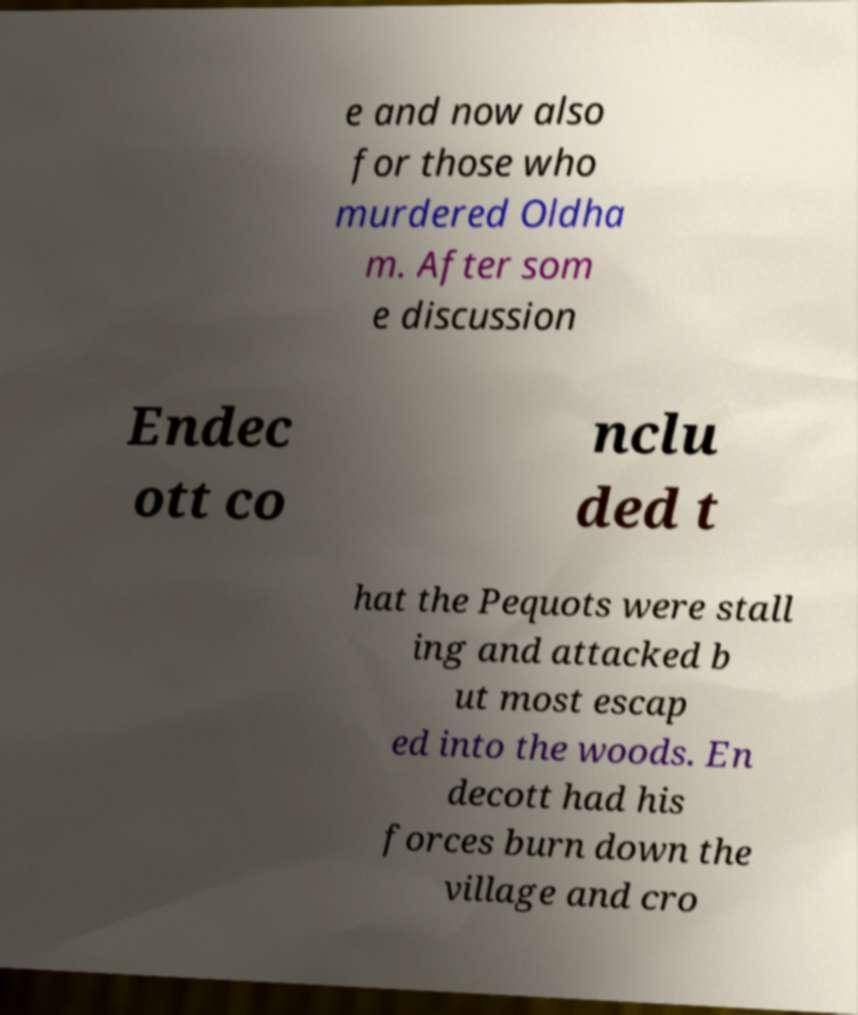Can you accurately transcribe the text from the provided image for me? e and now also for those who murdered Oldha m. After som e discussion Endec ott co nclu ded t hat the Pequots were stall ing and attacked b ut most escap ed into the woods. En decott had his forces burn down the village and cro 